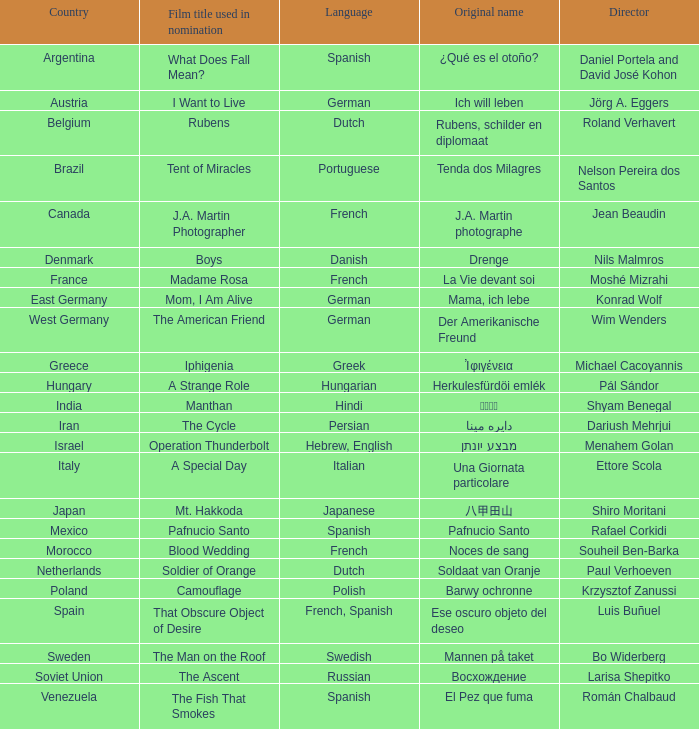Which nation does the director roland verhavert originate from? Belgium. 